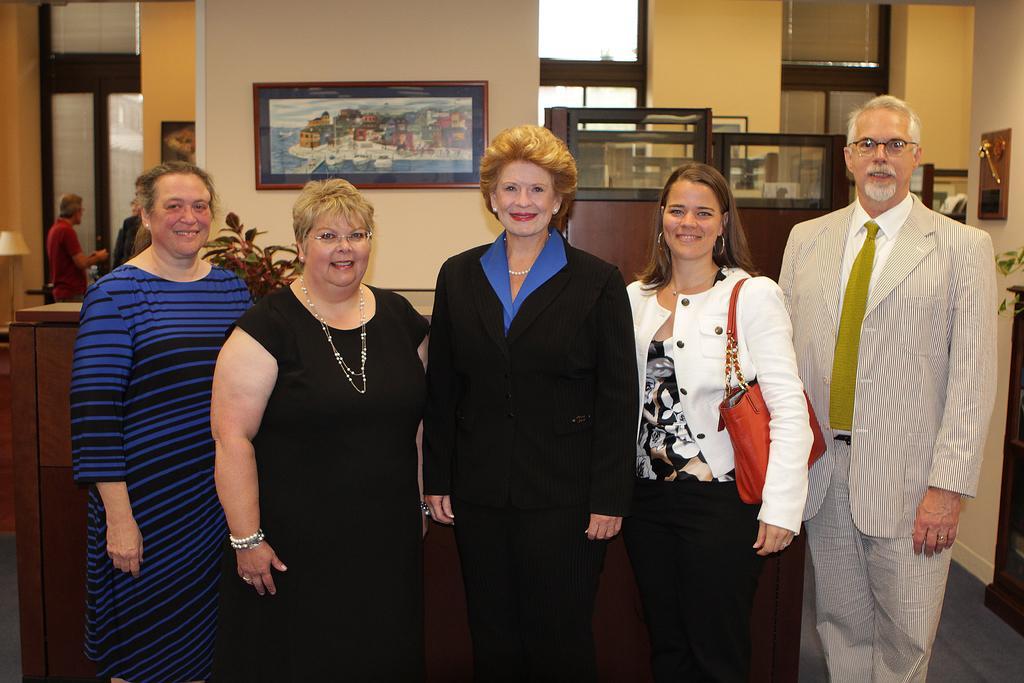Could you give a brief overview of what you see in this image? In front of the image there are people having a smile on their faces. Behind them there is a table. In the background of the image there are photo frame on the wall. On the right side of the image there is a flower pot on the wooden table. There is a lamp. There are people standing. 